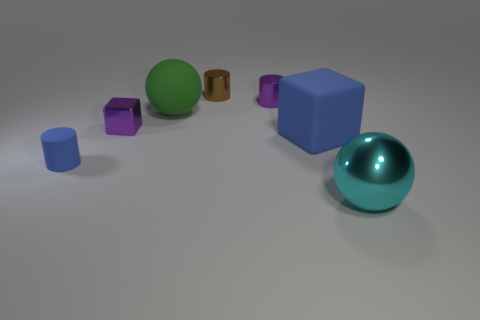Subtract all metallic cylinders. How many cylinders are left? 1 Subtract all cylinders. How many objects are left? 4 Add 3 large cyan spheres. How many objects exist? 10 Subtract all tiny red matte things. Subtract all blue rubber objects. How many objects are left? 5 Add 3 tiny purple metallic blocks. How many tiny purple metallic blocks are left? 4 Add 2 tiny blue cylinders. How many tiny blue cylinders exist? 3 Subtract 0 cyan cylinders. How many objects are left? 7 